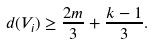Convert formula to latex. <formula><loc_0><loc_0><loc_500><loc_500>d ( V _ { i } ) \geq \frac { 2 m } { 3 } + \frac { k - 1 } { 3 } .</formula> 